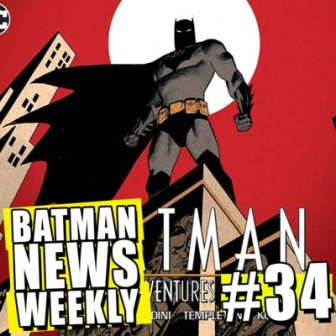Imagine Batman is not only a superhero but a detective solving a mystery. How does the cover reflect his dual role? The cover highlights Batman’s dual role as both a superhero and a detective through its clever use of visual symbolism. The red backdrop indicates a sense of urgency and danger typical in a crime-ridden city. Batman's imposing stance on the building conveys his heroic duties, protecting the city from high above. However, Batman’s distant gaze and the shadowy ambiance suggest contemplation and strategic planning, key traits of a detective unraveling mysteries. The contrast between the dark and light elements embodies the perpetual struggle between good and evil, a central theme in many of Batman’s detective endeavors. 